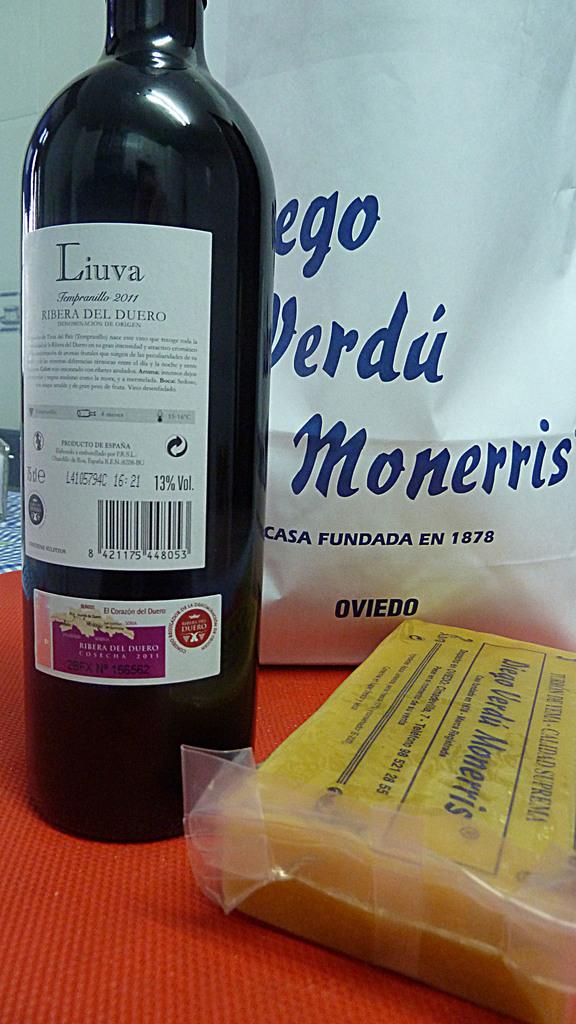What kind of wine can i find here?
Keep it short and to the point. Liuva. What is the brand of cheese?
Offer a very short reply. Diego verdu monerris. 